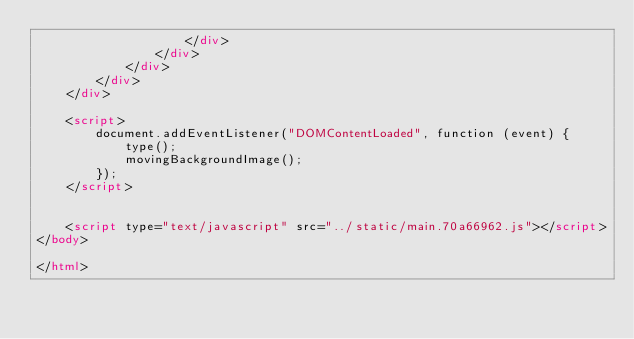<code> <loc_0><loc_0><loc_500><loc_500><_HTML_>                    </div>
                </div>
            </div>
        </div>
    </div>

    <script>
        document.addEventListener("DOMContentLoaded", function (event) {
            type();
            movingBackgroundImage();
        });
    </script>


    <script type="text/javascript" src="../static/main.70a66962.js"></script>
</body>

</html></code> 